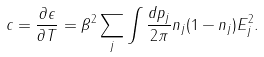Convert formula to latex. <formula><loc_0><loc_0><loc_500><loc_500>c = \frac { \partial \epsilon } { \partial T } = \beta ^ { 2 } \sum _ { j } \int \frac { d p _ { j } } { 2 \pi } n _ { j } ( 1 - n _ { j } ) E _ { j } ^ { 2 } .</formula> 